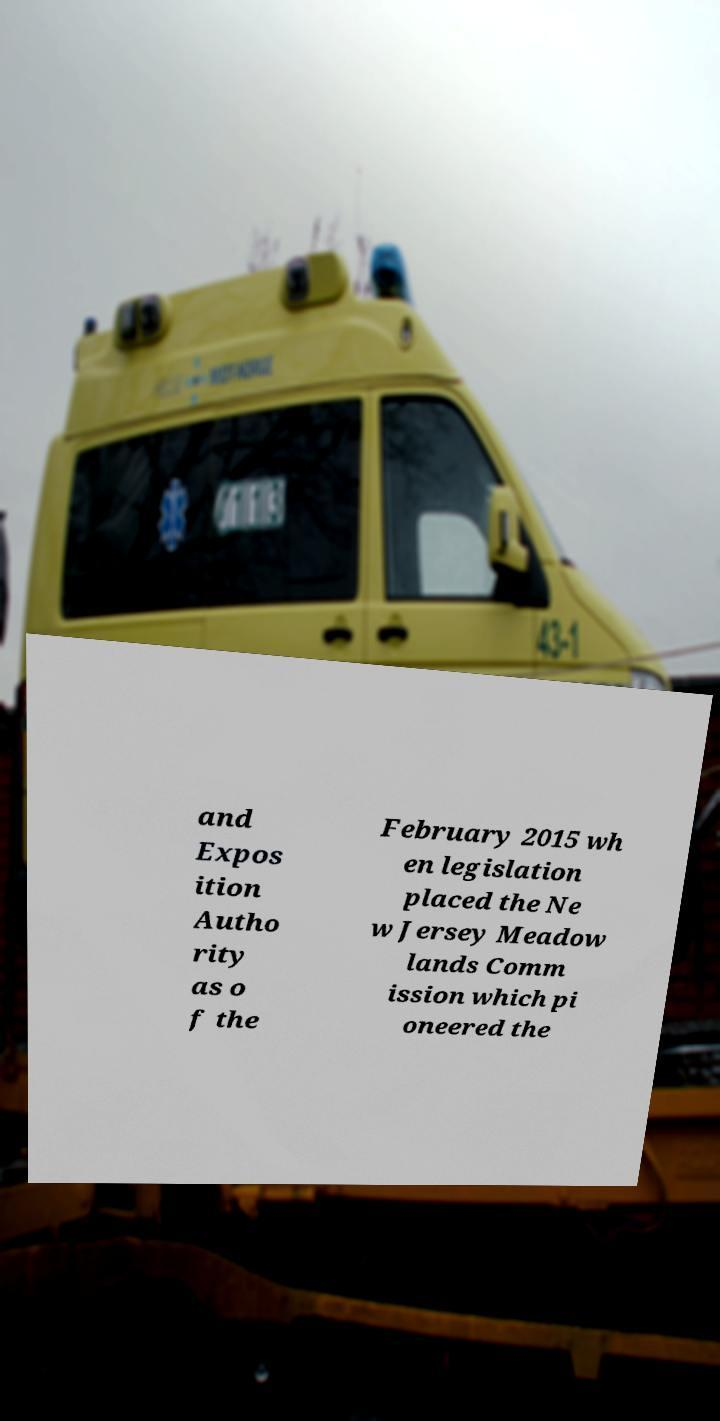Please identify and transcribe the text found in this image. and Expos ition Autho rity as o f the February 2015 wh en legislation placed the Ne w Jersey Meadow lands Comm ission which pi oneered the 